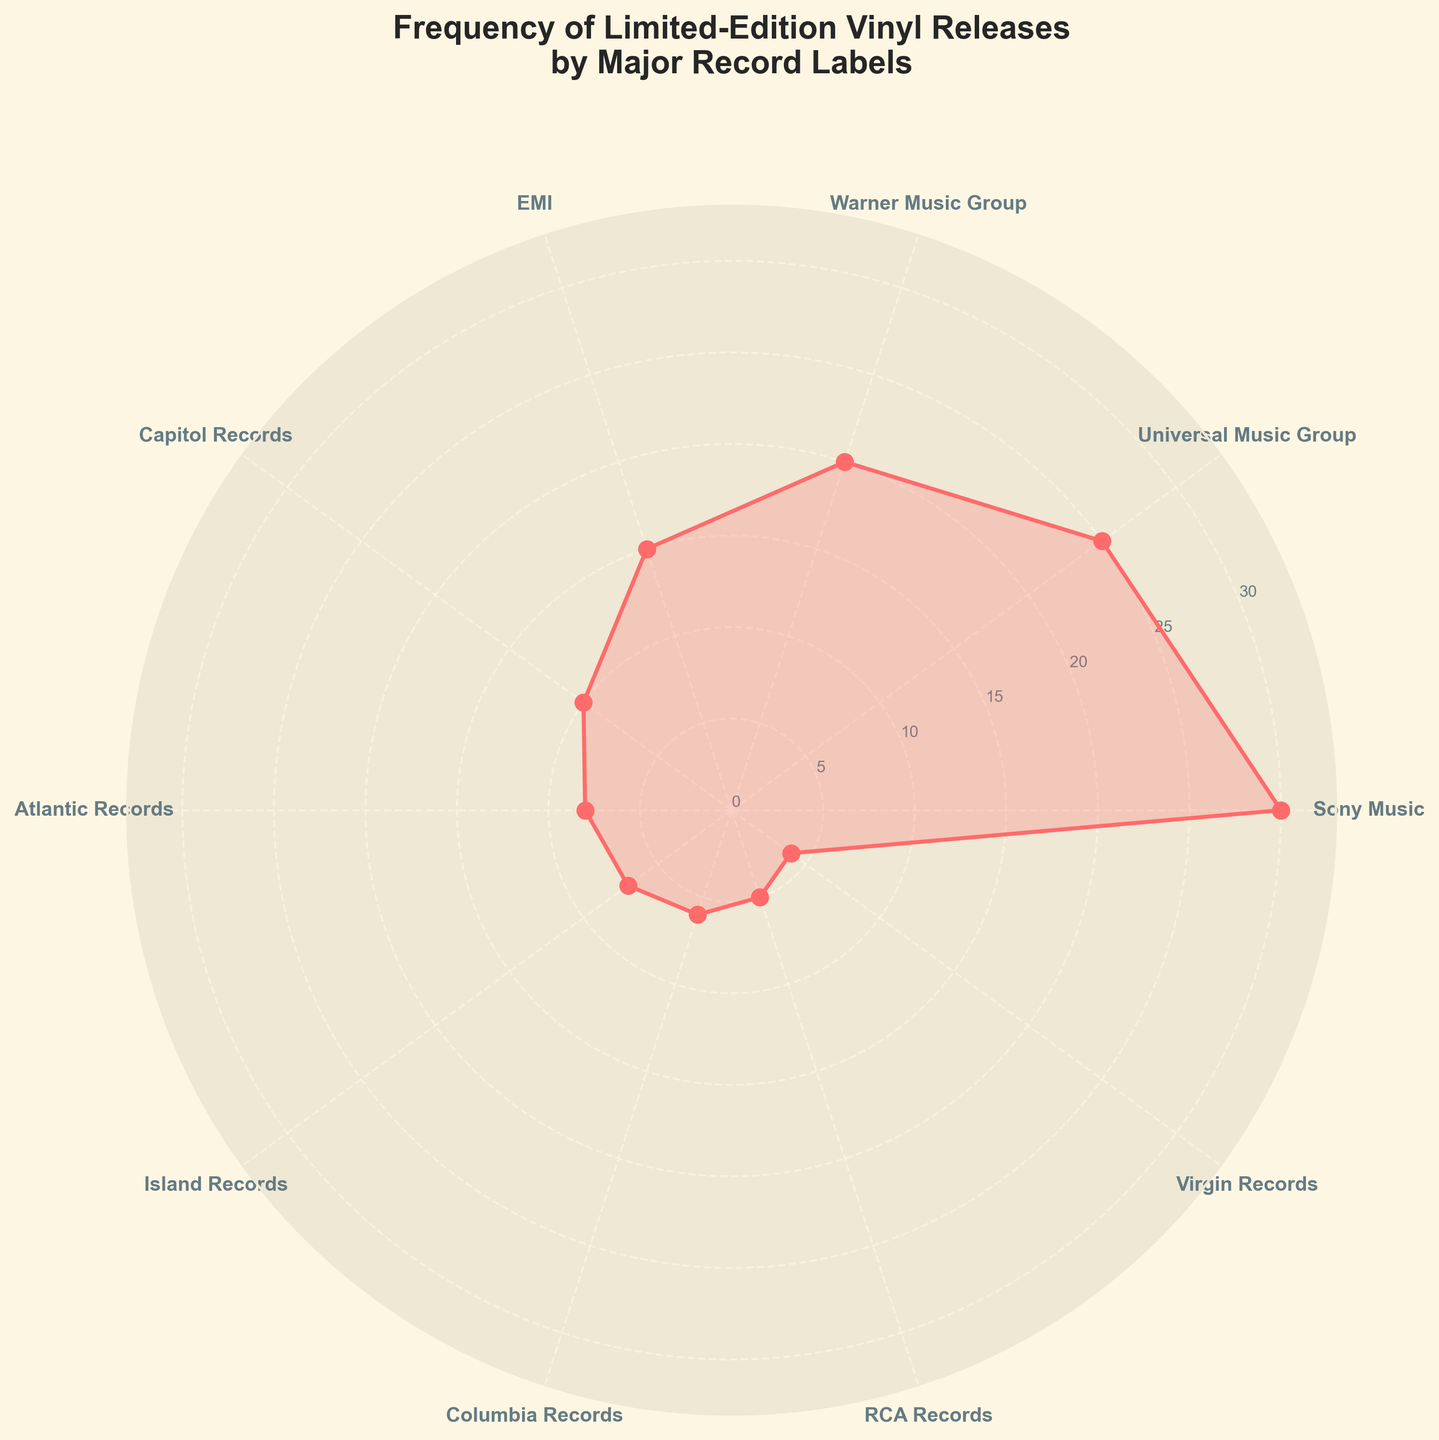what is the title of this figure? The title is usually at the top of the figure. In this case, the title is "Frequency of Limited-Edition Vinyl Releases by Major Record Labels."
Answer: Frequency of Limited-Edition Vinyl Releases by Major Record Labels Which record label has the highest frequency of limited-edition vinyl releases? By inspecting the plot, the longest bar or point on the chart represents the label with the highest frequency, which is Sony Music.
Answer: Sony Music What's the difference in the frequency of limited-edition vinyl releases between Sony Music and Virgin Records? Sony Music has a frequency of 30 and Virgin Records has a frequency of 4. The difference is 30 - 4 = 26.
Answer: 26 How many record labels have a frequency of 10 or higher? By inspecting the labels and their corresponding frequencies, those with frequencies of 10 or higher are Sony Music (30), Universal Music Group (25), Warner Music Group (20), EMI (15), and Capitol Records (10). This totals 5 labels.
Answer: 5 Which two record labels have the closest frequencies of limited-edition vinyl releases? By examining the frequencies, Atlantic Records (8) and Island Records (7) are the closest, with a difference of only 1.
Answer: Atlantic Records and Island Records What is the average frequency of limited-edition vinyl releases for all the record labels? Sum all the frequencies (30+25+20+15+10+8+7+6+5+4 = 130) and divide by the number of labels (10). The average is 130 / 10 = 13.
Answer: 13 Does Capitol Records have a higher or lower frequency of releases compared to Warner Music Group? Capitol Records is at 10, whereas Warner Music Group is at 20. Therefore, Warner Music Group has a higher frequency of releases.
Answer: Lower What is the total frequency of limited-edition vinyl releases for Columbia Records, RCA Records, and Virgin Records combined? The frequencies are 6 (Columbia Records), 5 (RCA Records), and 4 (Virgin Records). The total is 6 + 5 + 4 = 15.
Answer: 15 Which label is ranked 3rd in terms of frequency of limited-edition vinyl releases? By inspecting the frequencies, the third-highest frequency is Warner Music Group with 20.
Answer: Warner Music Group What is the median frequency of limited-edition vinyl releases? Sorting the frequencies: 4, 5, 6, 7, 8, 10, 15, 20, 25, 30. Since there are 10 records, the median frequency is the average of the 5th and 6th values: (8+10)/2 = 9.
Answer: 9 